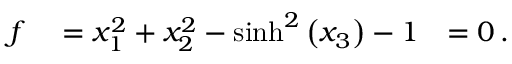<formula> <loc_0><loc_0><loc_500><loc_500>\begin{array} { r l r } { f } & = x _ { 1 } ^ { 2 } + x _ { 2 } ^ { 2 } - \sinh ^ { 2 } \left ( x _ { 3 } \right ) - 1 } & { = 0 \, . } \end{array}</formula> 